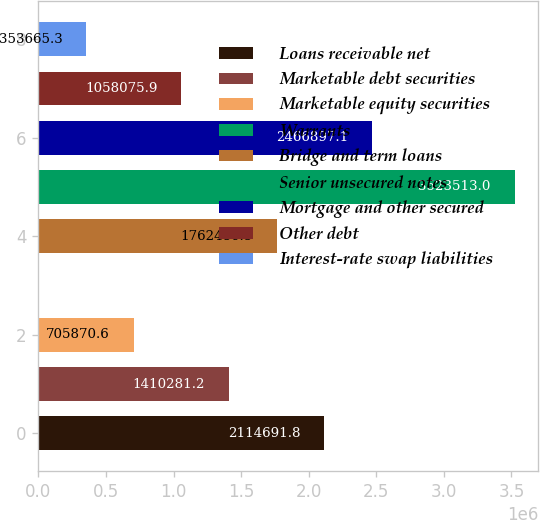Convert chart to OTSL. <chart><loc_0><loc_0><loc_500><loc_500><bar_chart><fcel>Loans receivable net<fcel>Marketable debt securities<fcel>Marketable equity securities<fcel>Warrants<fcel>Bridge and term loans<fcel>Senior unsecured notes<fcel>Mortgage and other secured<fcel>Other debt<fcel>Interest-rate swap liabilities<nl><fcel>2.11469e+06<fcel>1.41028e+06<fcel>705871<fcel>1460<fcel>1.76249e+06<fcel>3.52351e+06<fcel>2.4669e+06<fcel>1.05808e+06<fcel>353665<nl></chart> 